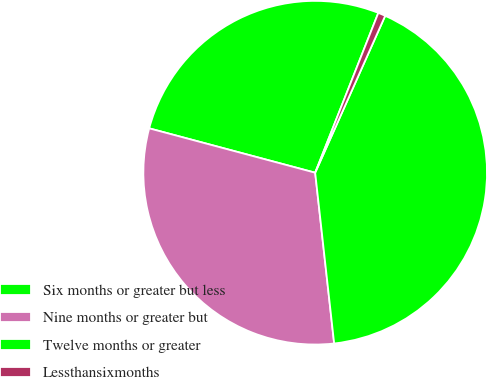Convert chart. <chart><loc_0><loc_0><loc_500><loc_500><pie_chart><fcel>Six months or greater but less<fcel>Nine months or greater but<fcel>Twelve months or greater<fcel>Lessthansixmonths<nl><fcel>26.83%<fcel>30.92%<fcel>41.56%<fcel>0.69%<nl></chart> 